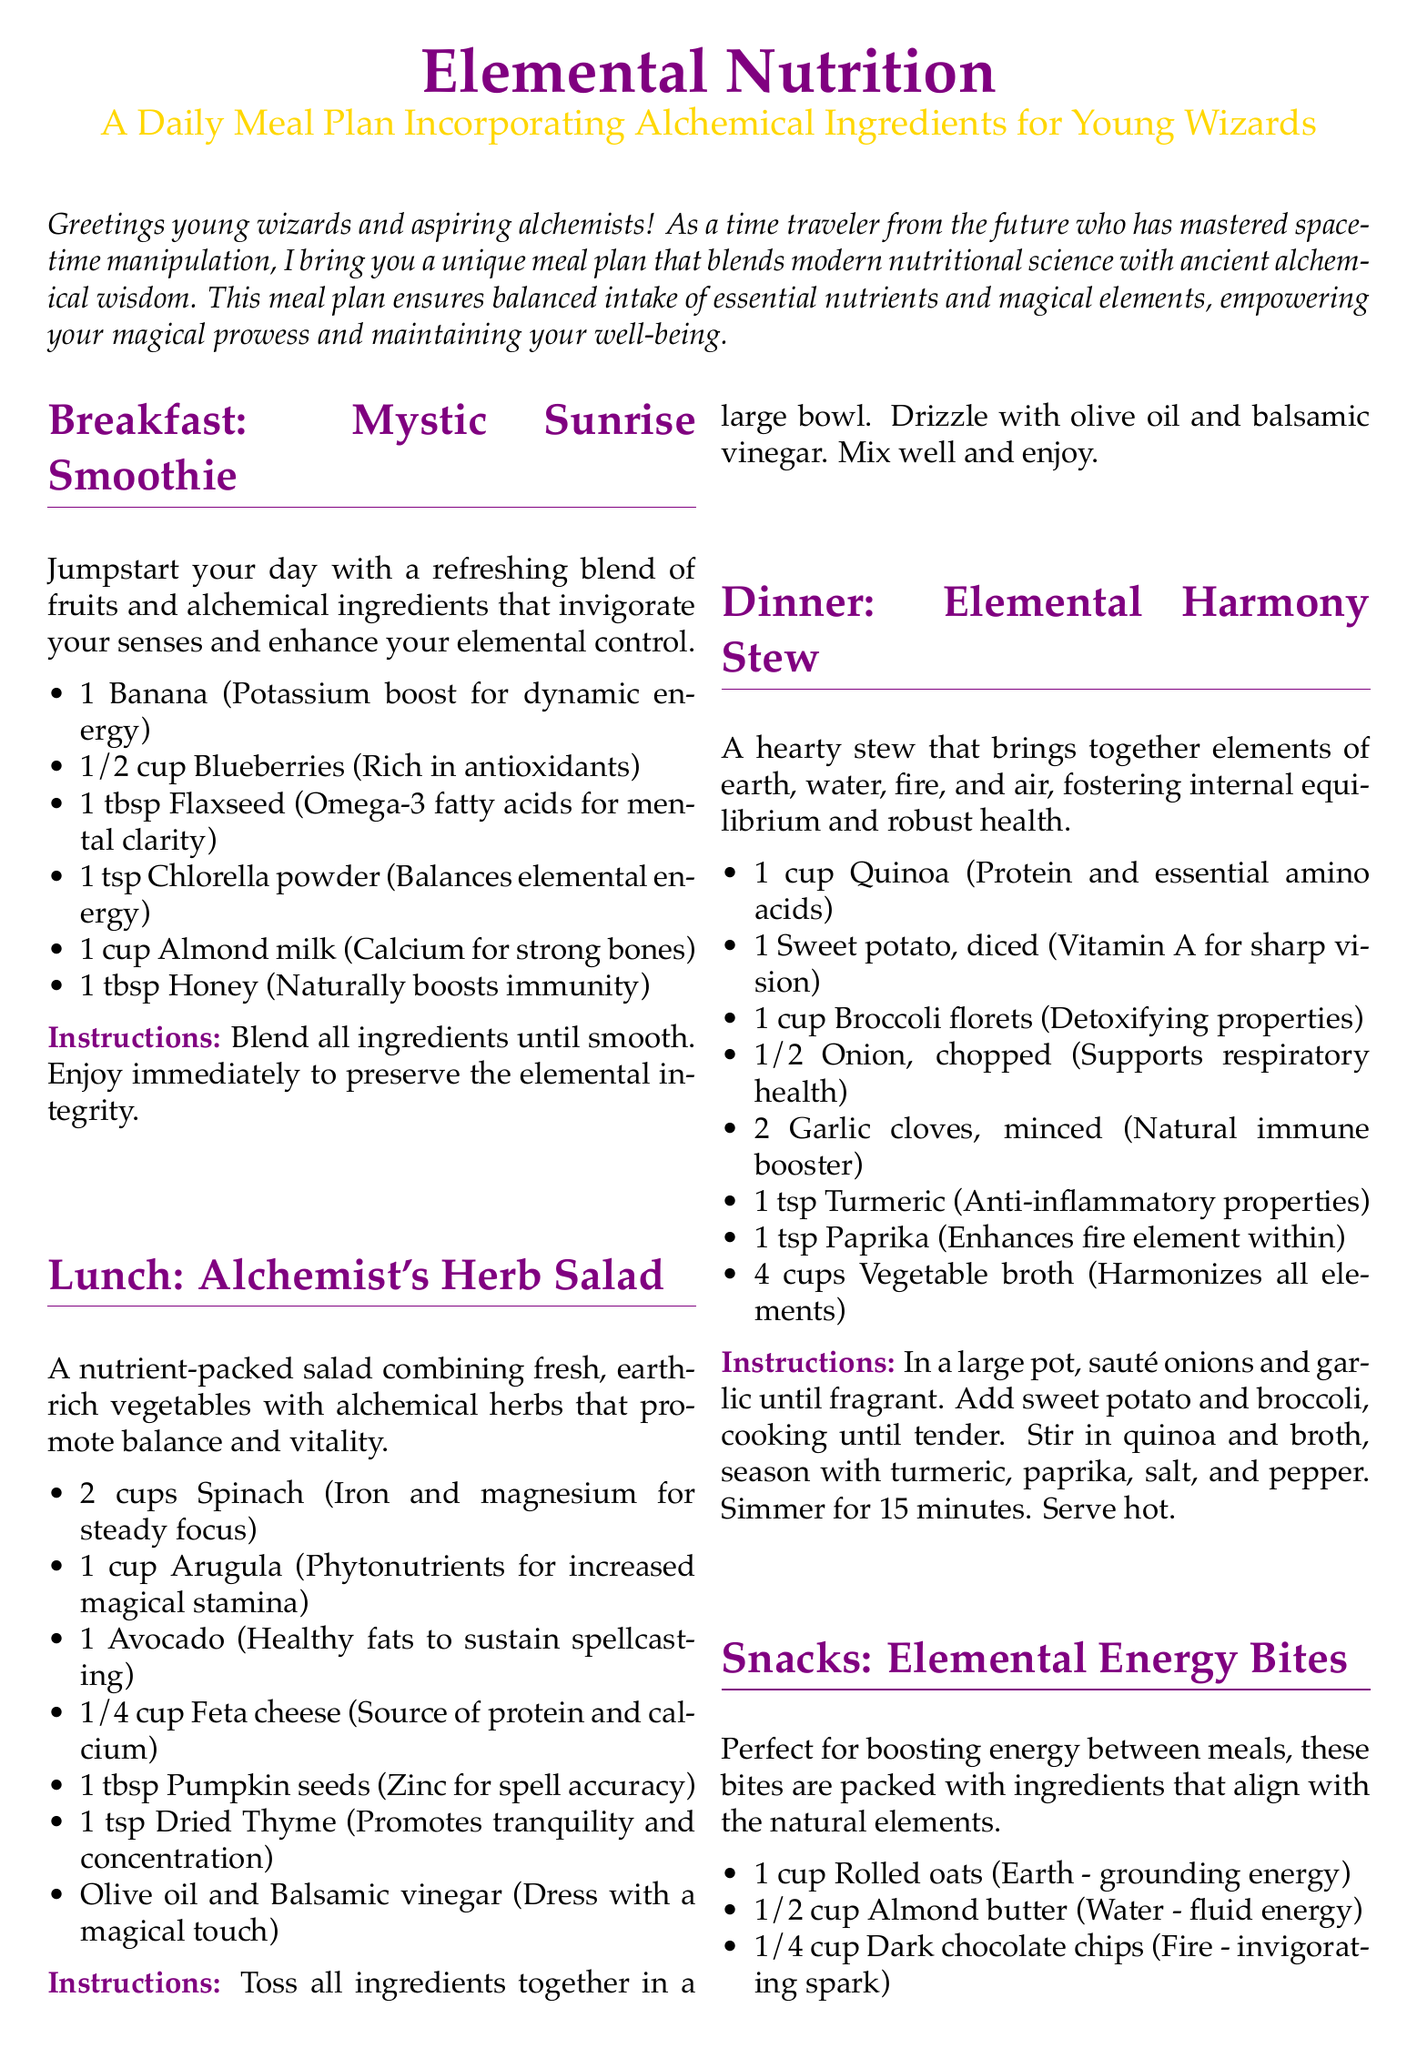What is the title of the breakfast item? The title is indicated in the "section" heading for breakfast in the document.
Answer: Mystic Sunrise Smoothie How many cups of spinach are in the lunch recipe? The amount of spinach is listed in the ingredient list for the lunch item.
Answer: 2 cups What is the main cooking method for the Elemental Harmony Stew? The instructions outline the method used for cooking the dinner item.
Answer: Sauté How many ingredients are in the Elemental Energy Bites? The number of ingredients can be counted from the ingredient list provided in the snacks section.
Answer: 5 What is the primary ingredient that enhances focus in the beverage recipe? The beverage's ingredient list includes items aimed at enhancing focus, specifically stated in the ingredient descriptions.
Answer: Lemon balm Which ingredient in the breakfast promotes mental clarity? This information is found in the description of the specific ingredient in the breakfast recipe.
Answer: Flaxseed How long should the herbal tea be steeped? The steeping time is stated in the instructions for making the beverage.
Answer: 7-10 minutes What is the color used for the section headings in the document? The color for headings is specified in the document's formatting sections.
Answer: wizardpurple 